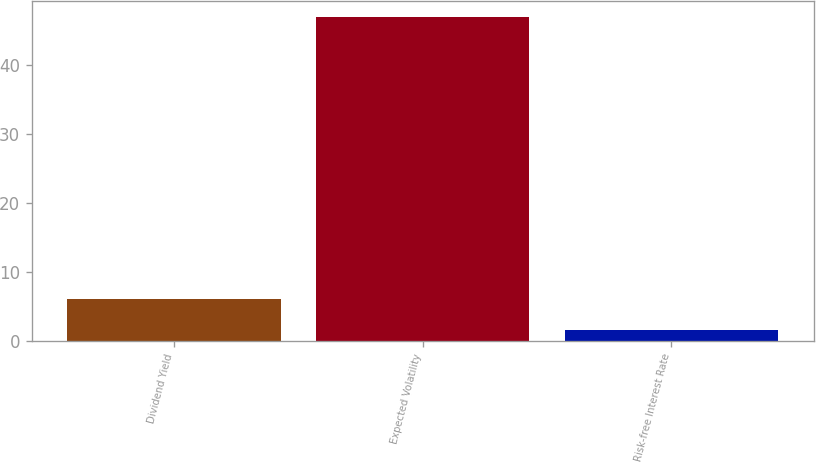Convert chart to OTSL. <chart><loc_0><loc_0><loc_500><loc_500><bar_chart><fcel>Dividend Yield<fcel>Expected Volatility<fcel>Risk-free Interest Rate<nl><fcel>6.11<fcel>46.99<fcel>1.57<nl></chart> 